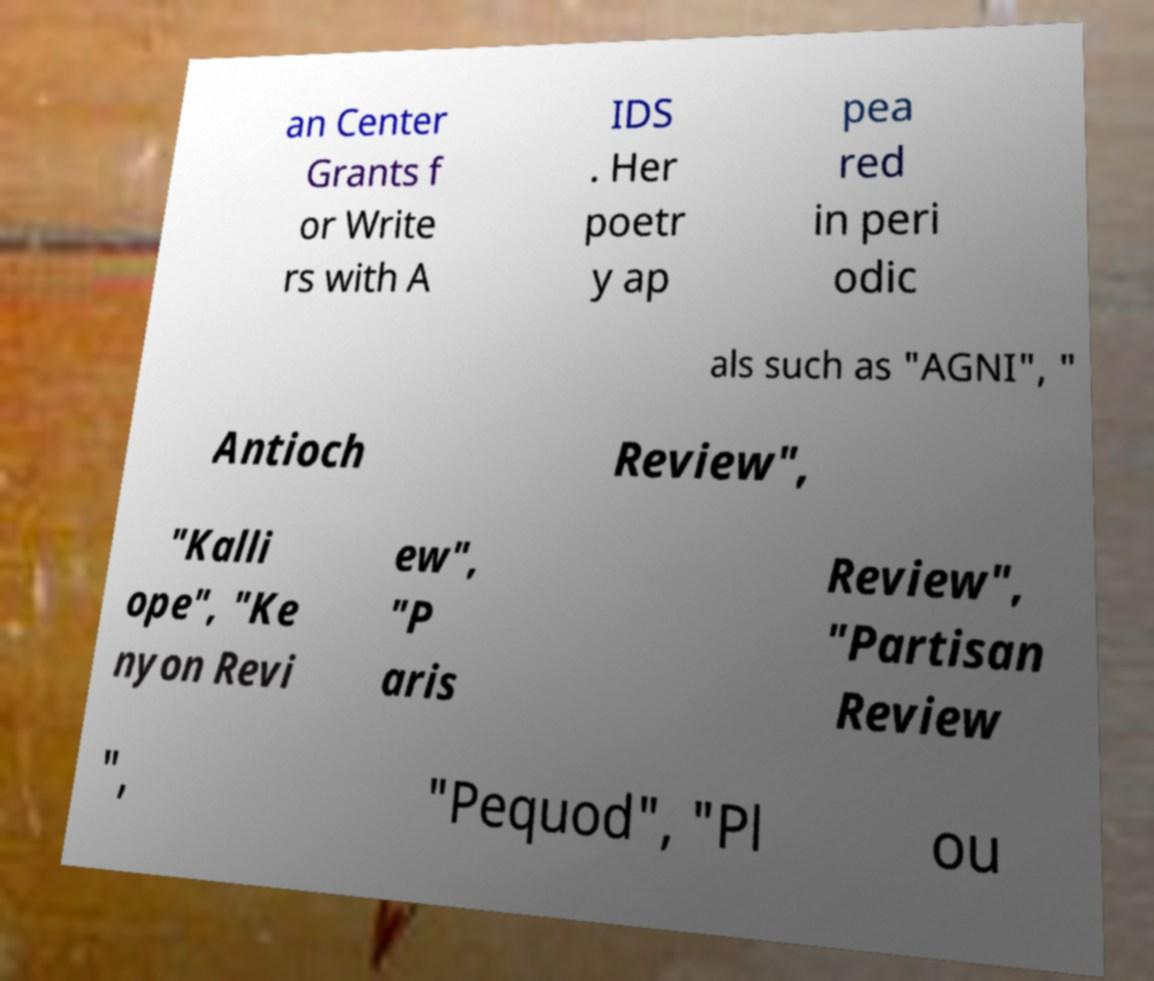There's text embedded in this image that I need extracted. Can you transcribe it verbatim? an Center Grants f or Write rs with A IDS . Her poetr y ap pea red in peri odic als such as "AGNI", " Antioch Review", "Kalli ope", "Ke nyon Revi ew", "P aris Review", "Partisan Review ", "Pequod", "Pl ou 